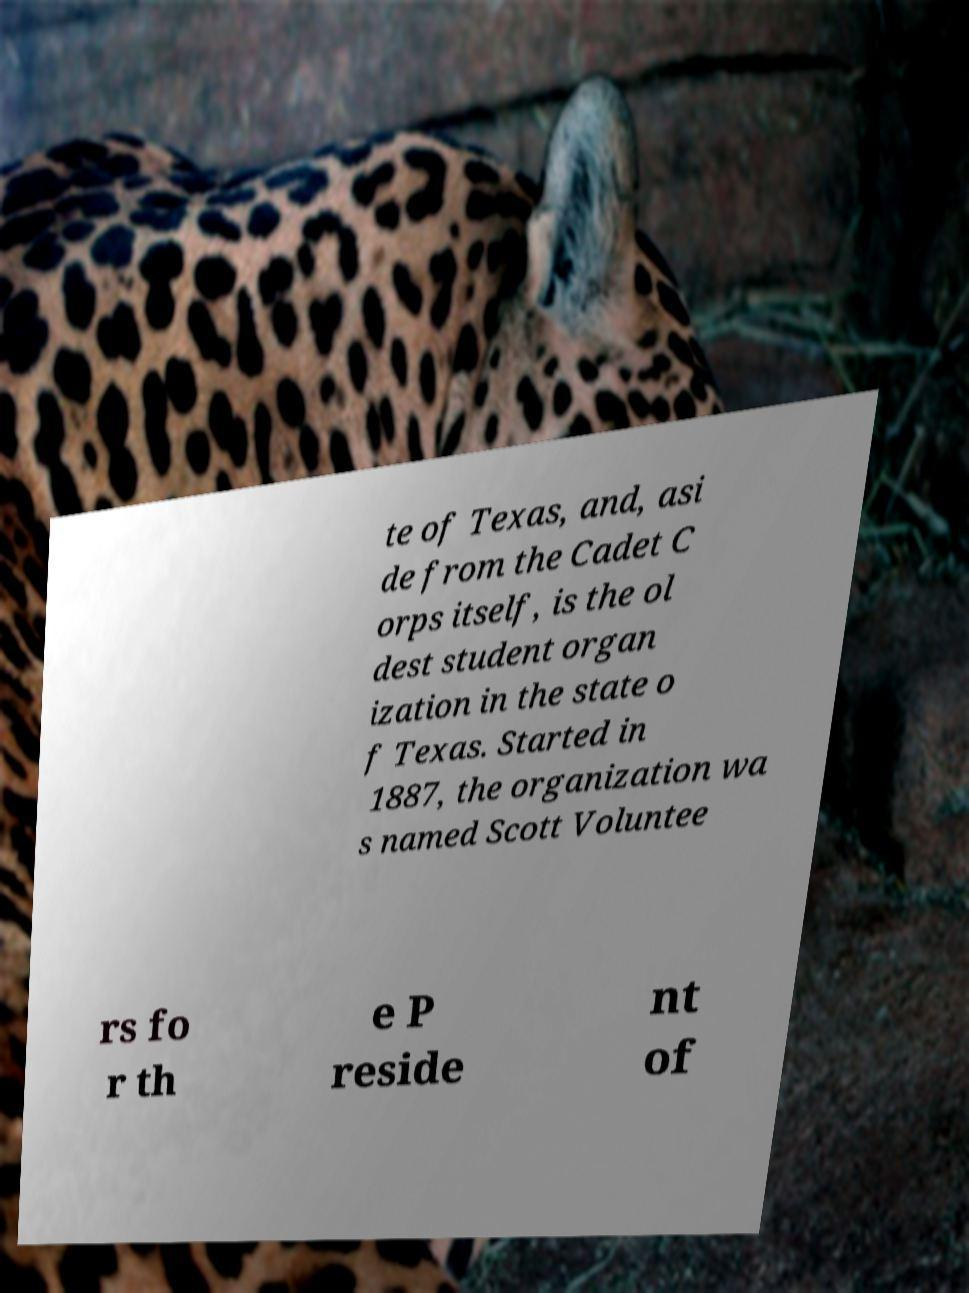What messages or text are displayed in this image? I need them in a readable, typed format. te of Texas, and, asi de from the Cadet C orps itself, is the ol dest student organ ization in the state o f Texas. Started in 1887, the organization wa s named Scott Voluntee rs fo r th e P reside nt of 